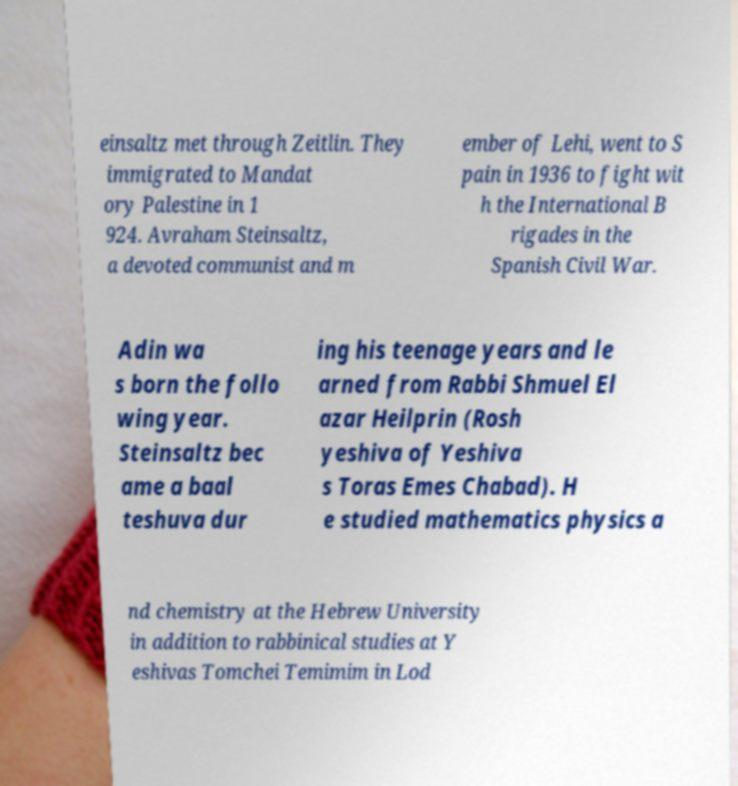Can you read and provide the text displayed in the image?This photo seems to have some interesting text. Can you extract and type it out for me? einsaltz met through Zeitlin. They immigrated to Mandat ory Palestine in 1 924. Avraham Steinsaltz, a devoted communist and m ember of Lehi, went to S pain in 1936 to fight wit h the International B rigades in the Spanish Civil War. Adin wa s born the follo wing year. Steinsaltz bec ame a baal teshuva dur ing his teenage years and le arned from Rabbi Shmuel El azar Heilprin (Rosh yeshiva of Yeshiva s Toras Emes Chabad). H e studied mathematics physics a nd chemistry at the Hebrew University in addition to rabbinical studies at Y eshivas Tomchei Temimim in Lod 